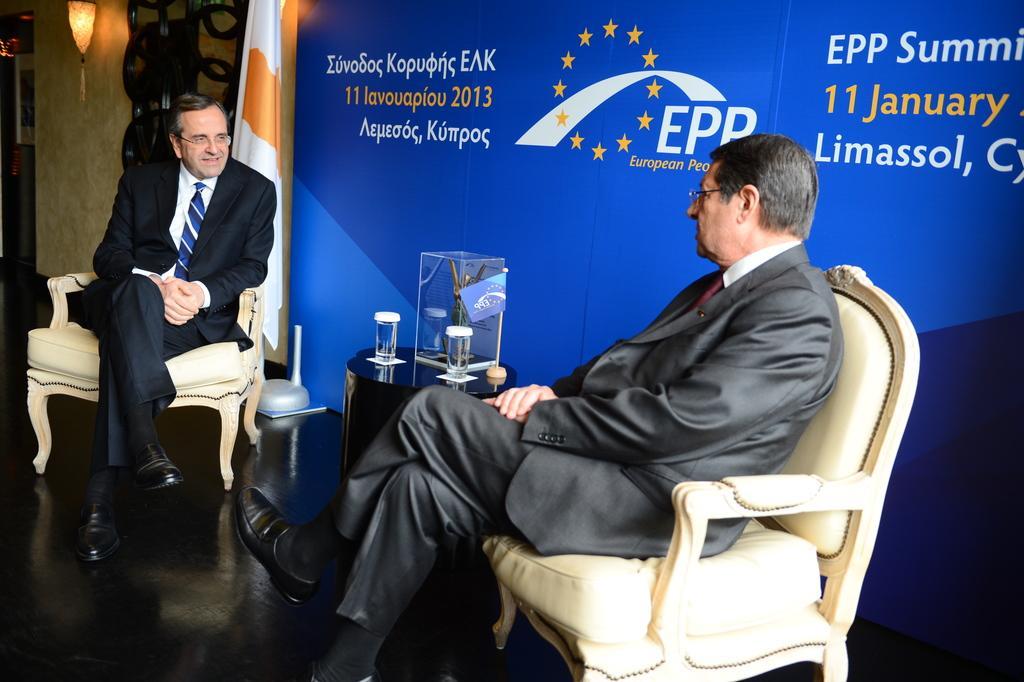In one or two sentences, can you explain what this image depicts? This picture shows there are two men sitting on the chair and one of them was smiling and other man is looking at him, behind them there is a flag and a banner 